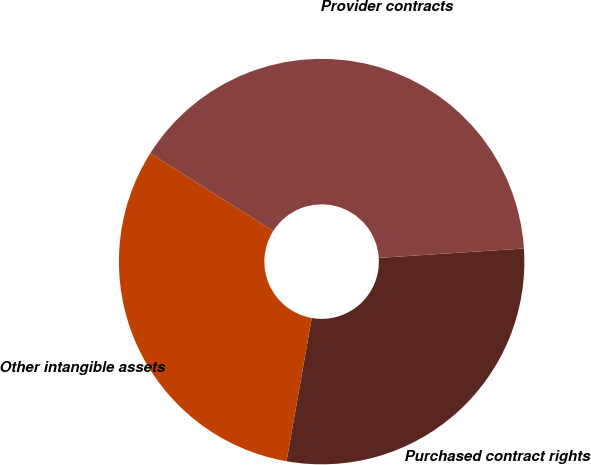<chart> <loc_0><loc_0><loc_500><loc_500><pie_chart><fcel>Purchased contract rights<fcel>Provider contracts<fcel>Other intangible assets<nl><fcel>28.8%<fcel>40.0%<fcel>31.2%<nl></chart> 